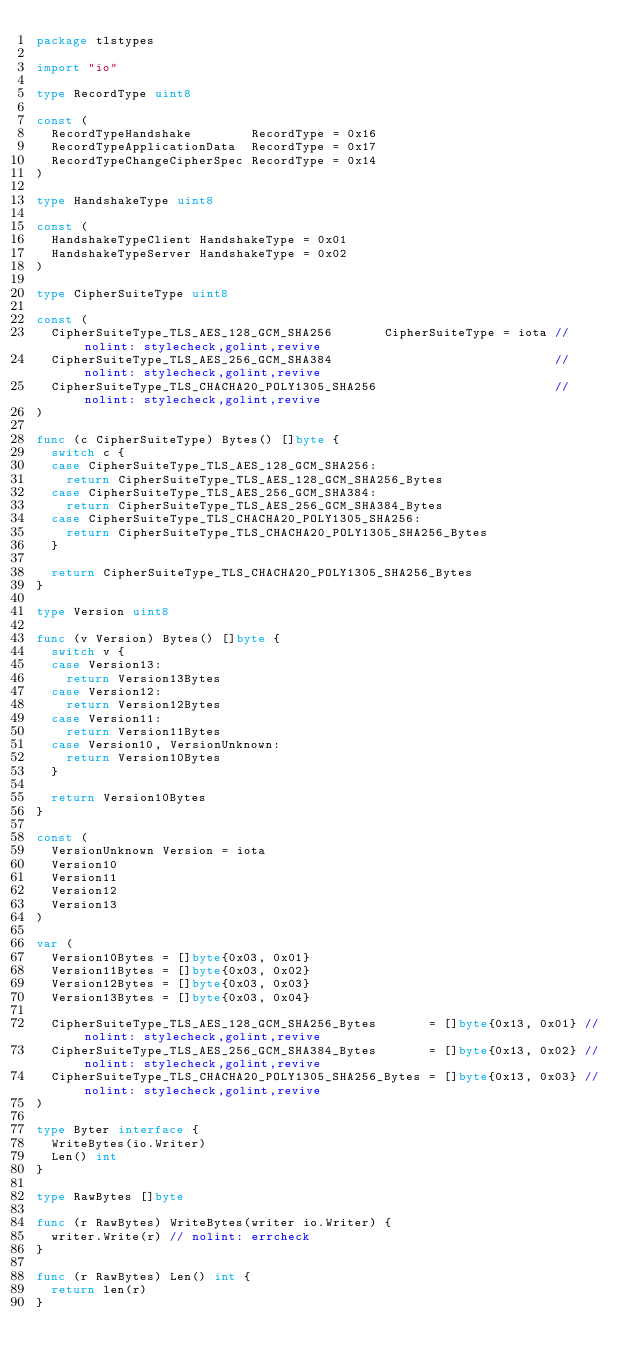Convert code to text. <code><loc_0><loc_0><loc_500><loc_500><_Go_>package tlstypes

import "io"

type RecordType uint8

const (
	RecordTypeHandshake        RecordType = 0x16
	RecordTypeApplicationData  RecordType = 0x17
	RecordTypeChangeCipherSpec RecordType = 0x14
)

type HandshakeType uint8

const (
	HandshakeTypeClient HandshakeType = 0x01
	HandshakeTypeServer HandshakeType = 0x02
)

type CipherSuiteType uint8

const (
	CipherSuiteType_TLS_AES_128_GCM_SHA256       CipherSuiteType = iota // nolint: stylecheck,golint,revive
	CipherSuiteType_TLS_AES_256_GCM_SHA384                              // nolint: stylecheck,golint,revive
	CipherSuiteType_TLS_CHACHA20_POLY1305_SHA256                        // nolint: stylecheck,golint,revive
)

func (c CipherSuiteType) Bytes() []byte {
	switch c {
	case CipherSuiteType_TLS_AES_128_GCM_SHA256:
		return CipherSuiteType_TLS_AES_128_GCM_SHA256_Bytes
	case CipherSuiteType_TLS_AES_256_GCM_SHA384:
		return CipherSuiteType_TLS_AES_256_GCM_SHA384_Bytes
	case CipherSuiteType_TLS_CHACHA20_POLY1305_SHA256:
		return CipherSuiteType_TLS_CHACHA20_POLY1305_SHA256_Bytes
	}

	return CipherSuiteType_TLS_CHACHA20_POLY1305_SHA256_Bytes
}

type Version uint8

func (v Version) Bytes() []byte {
	switch v {
	case Version13:
		return Version13Bytes
	case Version12:
		return Version12Bytes
	case Version11:
		return Version11Bytes
	case Version10, VersionUnknown:
		return Version10Bytes
	}

	return Version10Bytes
}

const (
	VersionUnknown Version = iota
	Version10
	Version11
	Version12
	Version13
)

var (
	Version10Bytes = []byte{0x03, 0x01}
	Version11Bytes = []byte{0x03, 0x02}
	Version12Bytes = []byte{0x03, 0x03}
	Version13Bytes = []byte{0x03, 0x04}

	CipherSuiteType_TLS_AES_128_GCM_SHA256_Bytes       = []byte{0x13, 0x01} // nolint: stylecheck,golint,revive
	CipherSuiteType_TLS_AES_256_GCM_SHA384_Bytes       = []byte{0x13, 0x02} // nolint: stylecheck,golint,revive
	CipherSuiteType_TLS_CHACHA20_POLY1305_SHA256_Bytes = []byte{0x13, 0x03} // nolint: stylecheck,golint,revive
)

type Byter interface {
	WriteBytes(io.Writer)
	Len() int
}

type RawBytes []byte

func (r RawBytes) WriteBytes(writer io.Writer) {
	writer.Write(r) // nolint: errcheck
}

func (r RawBytes) Len() int {
	return len(r)
}
</code> 